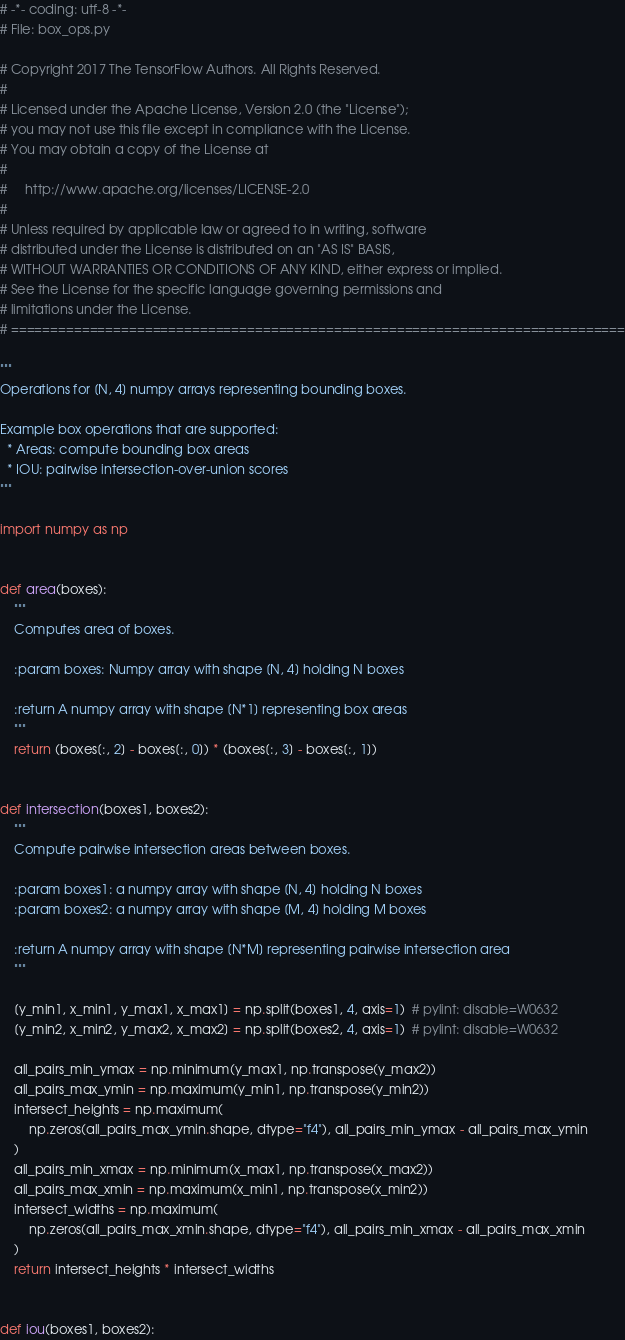<code> <loc_0><loc_0><loc_500><loc_500><_Python_># -*- coding: utf-8 -*-
# File: box_ops.py

# Copyright 2017 The TensorFlow Authors. All Rights Reserved.
#
# Licensed under the Apache License, Version 2.0 (the "License");
# you may not use this file except in compliance with the License.
# You may obtain a copy of the License at
#
#     http://www.apache.org/licenses/LICENSE-2.0
#
# Unless required by applicable law or agreed to in writing, software
# distributed under the License is distributed on an "AS IS" BASIS,
# WITHOUT WARRANTIES OR CONDITIONS OF ANY KIND, either express or implied.
# See the License for the specific language governing permissions and
# limitations under the License.
# ==============================================================================

"""
Operations for [N, 4] numpy arrays representing bounding boxes.

Example box operations that are supported:
  * Areas: compute bounding box areas
  * IOU: pairwise intersection-over-union scores
"""

import numpy as np


def area(boxes):
    """
    Computes area of boxes.

    :param boxes: Numpy array with shape [N, 4] holding N boxes

    :return A numpy array with shape [N*1] representing box areas
    """
    return (boxes[:, 2] - boxes[:, 0]) * (boxes[:, 3] - boxes[:, 1])


def intersection(boxes1, boxes2):
    """
    Compute pairwise intersection areas between boxes.

    :param boxes1: a numpy array with shape [N, 4] holding N boxes
    :param boxes2: a numpy array with shape [M, 4] holding M boxes

    :return A numpy array with shape [N*M] representing pairwise intersection area
    """

    [y_min1, x_min1, y_max1, x_max1] = np.split(boxes1, 4, axis=1)  # pylint: disable=W0632
    [y_min2, x_min2, y_max2, x_max2] = np.split(boxes2, 4, axis=1)  # pylint: disable=W0632

    all_pairs_min_ymax = np.minimum(y_max1, np.transpose(y_max2))
    all_pairs_max_ymin = np.maximum(y_min1, np.transpose(y_min2))
    intersect_heights = np.maximum(
        np.zeros(all_pairs_max_ymin.shape, dtype="f4"), all_pairs_min_ymax - all_pairs_max_ymin
    )
    all_pairs_min_xmax = np.minimum(x_max1, np.transpose(x_max2))
    all_pairs_max_xmin = np.maximum(x_min1, np.transpose(x_min2))
    intersect_widths = np.maximum(
        np.zeros(all_pairs_max_xmin.shape, dtype="f4"), all_pairs_min_xmax - all_pairs_max_xmin
    )
    return intersect_heights * intersect_widths


def iou(boxes1, boxes2):</code> 